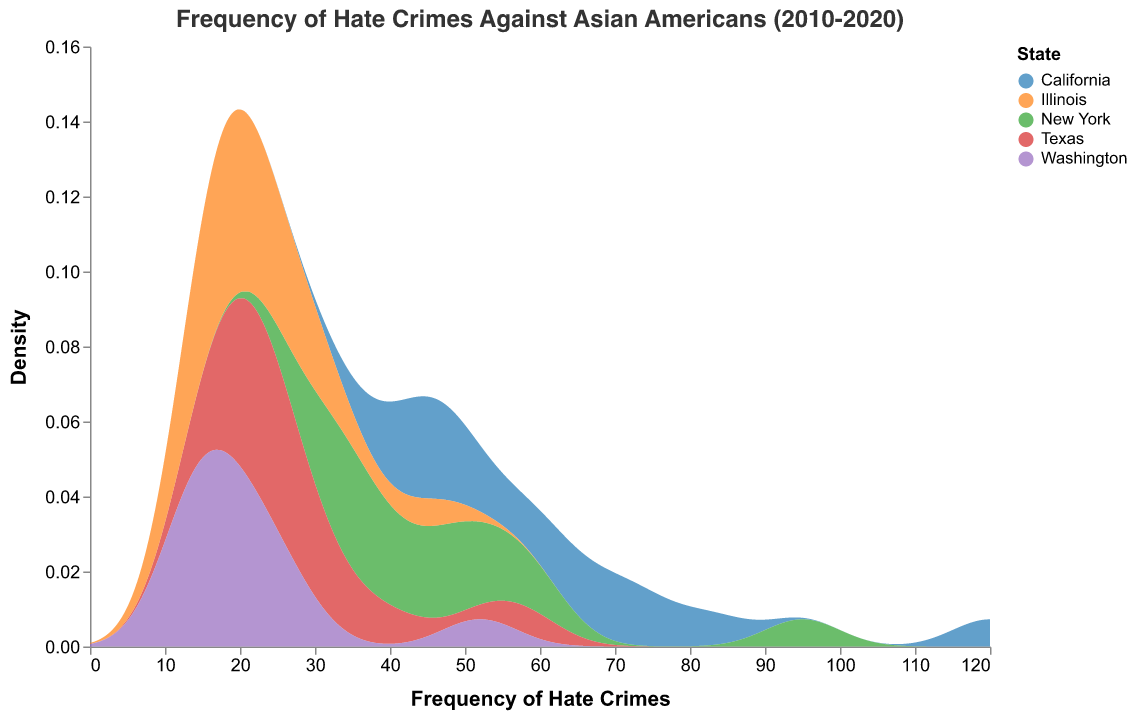What is the title of the plot? The title is displayed at the top of the plot and summarizes the figure's content.
Answer: Frequency of Hate Crimes Against Asian Americans (2010-2020) Which state has the highest frequency of hate crimes in 2020? By examining the density plot and noting the peak closest to the frequency of 120, we can determine the state from the legend.
Answer: California What is the density measurement for New York at a frequency of 60? Locate the density curve for New York (based on the color legend) and find the y-axis value corresponding to the frequency of 60 on the x-axis.
Answer: Approximately 0.022 How does the increase in the frequency of hate crimes in Texas compare from 2019 to 2020? Identify the density peaks for Texas in 2019 and 2020 and calculate the difference in frequency between these two years.
Answer: From 40 to 58, an increase of 18 Which state shows the lowest increase in hate crimes from 2010 to 2020? Compare the density peaks of all states at the frequencies corresponding to 2010 and 2020, then determine the state with the smallest difference.
Answer: Illinois What is the approximate average peak density value across all states? Note the peak density values from each state's density plot, sum them up, and divide by the number of states (5).
Answer: Approximately 0.024 How does the density distribution for Illinois differ from that of California? Compare the shapes and heights of the density plots for Illinois and California to note differences in spread and peak values.
Answer: Illinois has a lower and more gradual peak compared to California If we take the year 2015, which state's frequency of hate crimes is closest to the midpoint density value? Identify the midpoint along the y-axis and examine the density curves to see which state's density at the frequency for 2015 is closest.
Answer: New York 